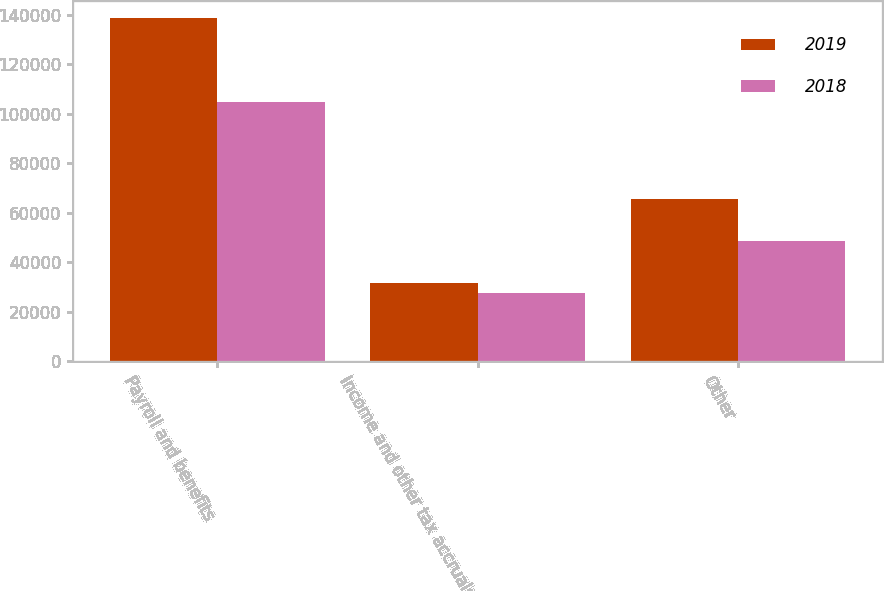Convert chart to OTSL. <chart><loc_0><loc_0><loc_500><loc_500><stacked_bar_chart><ecel><fcel>Payroll and benefits<fcel>Income and other tax accruals<fcel>Other<nl><fcel>2019<fcel>138453<fcel>31801<fcel>65615<nl><fcel>2018<fcel>104815<fcel>27656<fcel>48508<nl></chart> 